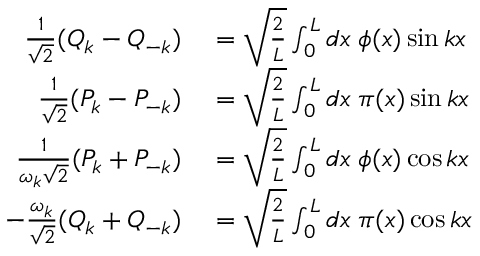Convert formula to latex. <formula><loc_0><loc_0><loc_500><loc_500>\begin{array} { r l } { \frac { 1 } { \sqrt { 2 } } ( Q _ { k } - Q _ { - k } ) } & = \sqrt { \frac { 2 } { L } } \int _ { 0 } ^ { L } d x \, \phi ( x ) \sin k x } \\ { \frac { 1 } { \sqrt { 2 } } ( P _ { k } - P _ { - k } ) } & = \sqrt { \frac { 2 } { L } } \int _ { 0 } ^ { L } d x \, \pi ( x ) \sin k x } \\ { \frac { 1 } { \omega _ { k } \sqrt { 2 } } ( P _ { k } + P _ { - k } ) } & = \sqrt { \frac { 2 } { L } } \int _ { 0 } ^ { L } d x \, \phi ( x ) \cos k x } \\ { - \frac { \omega _ { k } } { \sqrt { 2 } } ( Q _ { k } + Q _ { - k } ) } & = \sqrt { \frac { 2 } { L } } \int _ { 0 } ^ { L } d x \, \pi ( x ) \cos k x } \end{array}</formula> 